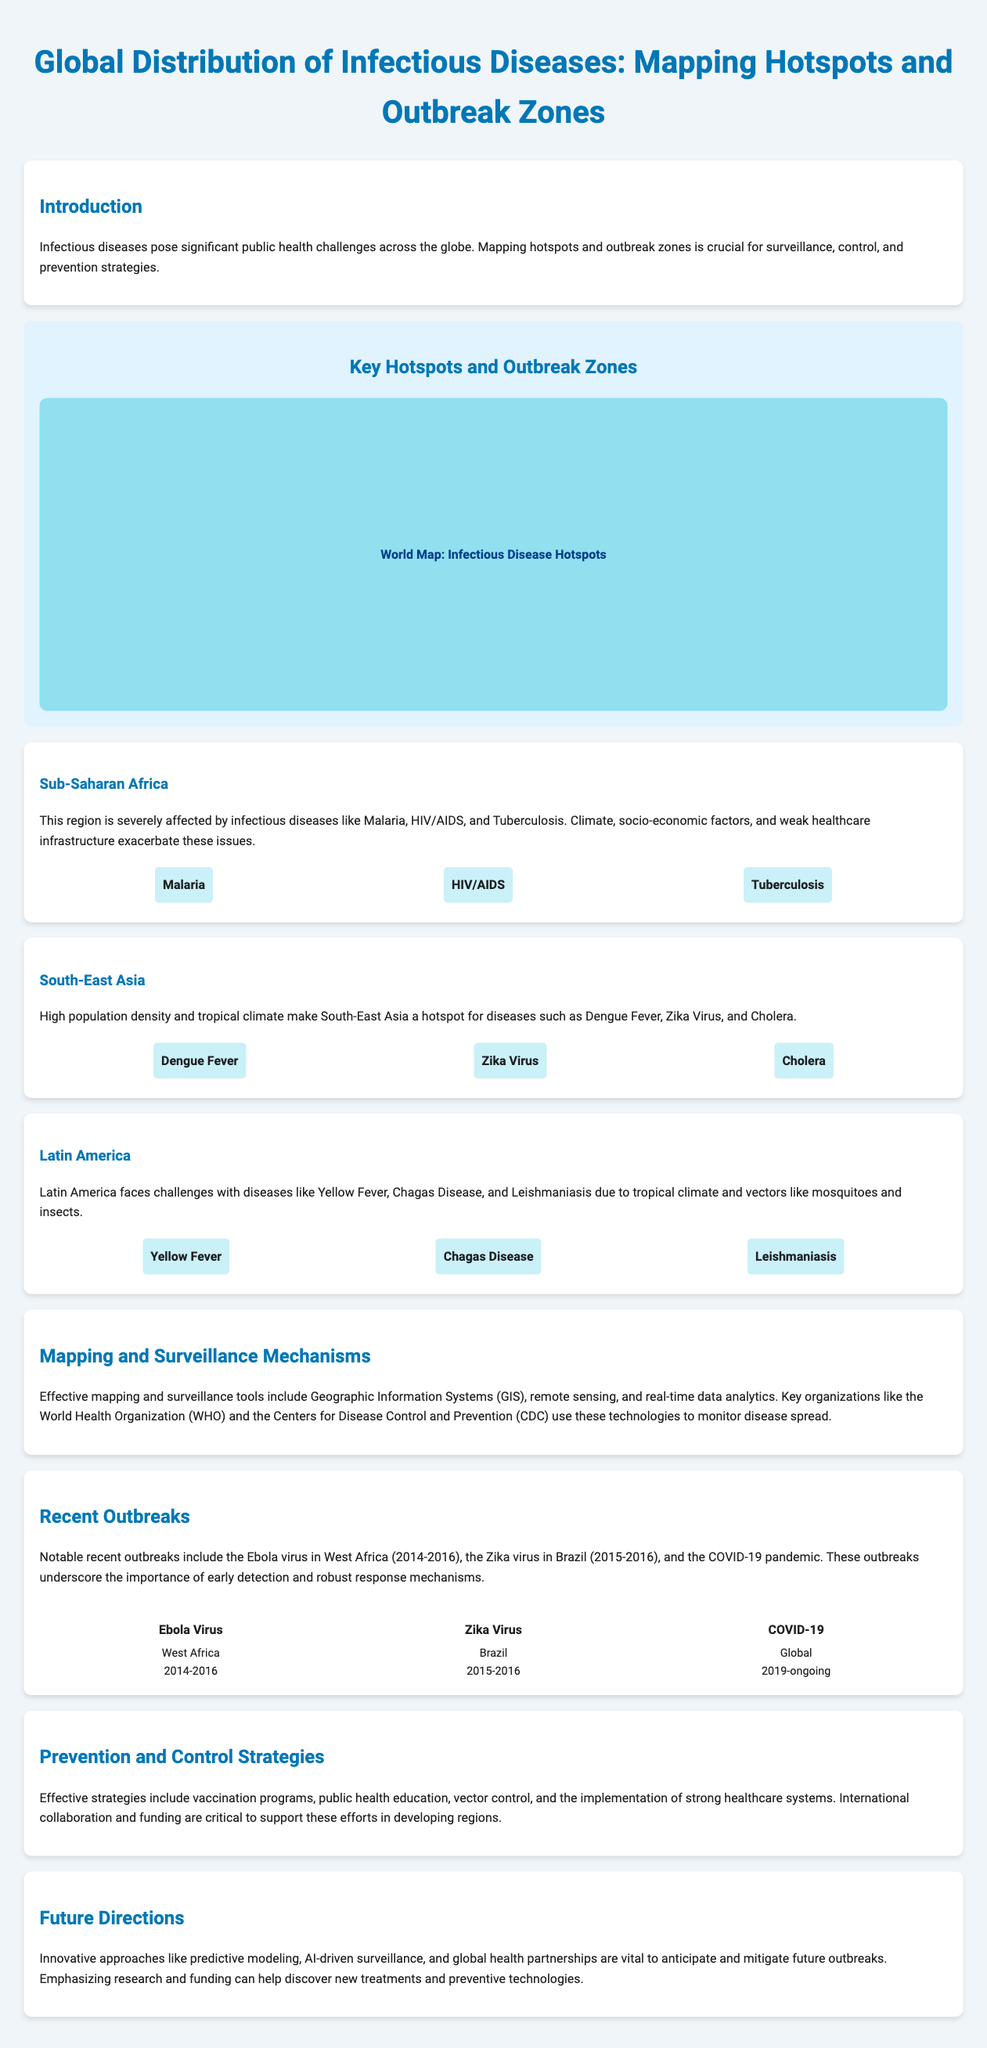What are the main infectious diseases in Sub-Saharan Africa? The document lists Malaria, HIV/AIDS, and Tuberculosis as the main infectious diseases in this region.
Answer: Malaria, HIV/AIDS, Tuberculosis Which region is noted for Dengue Fever, Zika Virus, and Cholera? The document mentions South-East Asia as the region known for these diseases.
Answer: South-East Asia What technology is emphasized for mapping and surveillance mechanisms? Geographic Information Systems (GIS), remote sensing, and real-time data analytics are highlighted in the document.
Answer: Geographic Information Systems (GIS) What notable outbreak occurred in West Africa between 2014 and 2016? The document refers to the Ebola virus outbreak in this region during those years.
Answer: Ebola Virus What preventive strategy is crucial for controlling infectious diseases? The document states that vaccination programs are a critical preventive strategy.
Answer: Vaccination programs How many recent outbreaks are listed in the document? The document mentions three recent outbreaks: Ebola, Zika, and COVID-19, thus listing a total of three.
Answer: Three What year did the COVID-19 pandemic begin? The document states that the COVID-19 pandemic began in 2019.
Answer: 2019 What does the document emphasize as vital for anticipating and mitigating future outbreaks? The document highlights the importance of innovative approaches like predictive modeling and AI-driven surveillance.
Answer: Predictive modeling, AI-driven surveillance What is a common theme in public health strategies mentioned in the document? The document reiterates that international collaboration is crucial for effective strategies in public health.
Answer: International collaboration 